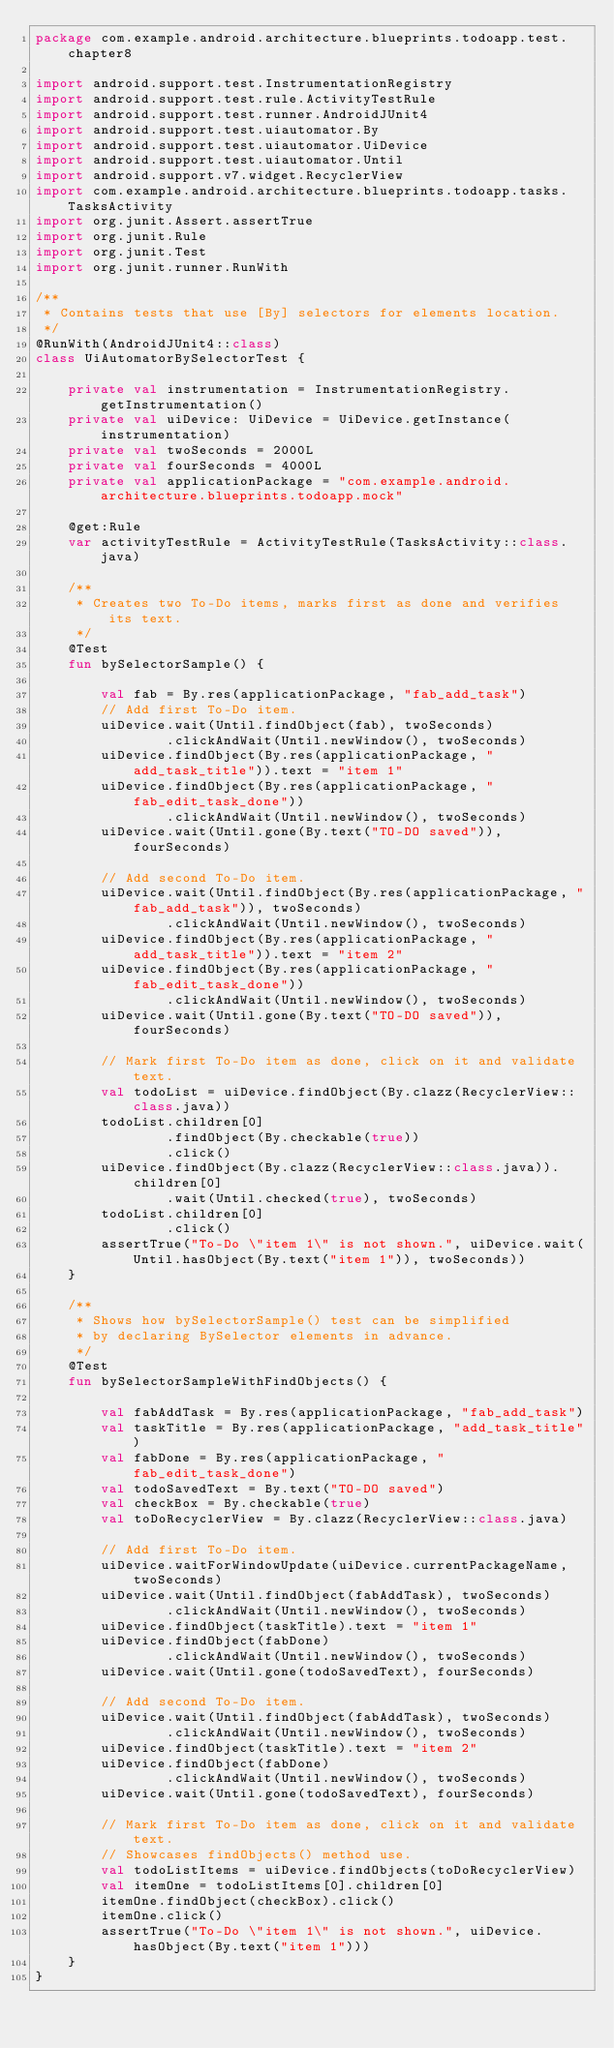Convert code to text. <code><loc_0><loc_0><loc_500><loc_500><_Kotlin_>package com.example.android.architecture.blueprints.todoapp.test.chapter8

import android.support.test.InstrumentationRegistry
import android.support.test.rule.ActivityTestRule
import android.support.test.runner.AndroidJUnit4
import android.support.test.uiautomator.By
import android.support.test.uiautomator.UiDevice
import android.support.test.uiautomator.Until
import android.support.v7.widget.RecyclerView
import com.example.android.architecture.blueprints.todoapp.tasks.TasksActivity
import org.junit.Assert.assertTrue
import org.junit.Rule
import org.junit.Test
import org.junit.runner.RunWith

/**
 * Contains tests that use [By] selectors for elements location.
 */
@RunWith(AndroidJUnit4::class)
class UiAutomatorBySelectorTest {

    private val instrumentation = InstrumentationRegistry.getInstrumentation()
    private val uiDevice: UiDevice = UiDevice.getInstance(instrumentation)
    private val twoSeconds = 2000L
    private val fourSeconds = 4000L
    private val applicationPackage = "com.example.android.architecture.blueprints.todoapp.mock"

    @get:Rule
    var activityTestRule = ActivityTestRule(TasksActivity::class.java)

    /**
     * Creates two To-Do items, marks first as done and verifies its text.
     */
    @Test
    fun bySelectorSample() {

        val fab = By.res(applicationPackage, "fab_add_task")
        // Add first To-Do item.
        uiDevice.wait(Until.findObject(fab), twoSeconds)
                .clickAndWait(Until.newWindow(), twoSeconds)
        uiDevice.findObject(By.res(applicationPackage, "add_task_title")).text = "item 1"
        uiDevice.findObject(By.res(applicationPackage, "fab_edit_task_done"))
                .clickAndWait(Until.newWindow(), twoSeconds)
        uiDevice.wait(Until.gone(By.text("TO-DO saved")), fourSeconds)

        // Add second To-Do item.
        uiDevice.wait(Until.findObject(By.res(applicationPackage, "fab_add_task")), twoSeconds)
                .clickAndWait(Until.newWindow(), twoSeconds)
        uiDevice.findObject(By.res(applicationPackage, "add_task_title")).text = "item 2"
        uiDevice.findObject(By.res(applicationPackage, "fab_edit_task_done"))
                .clickAndWait(Until.newWindow(), twoSeconds)
        uiDevice.wait(Until.gone(By.text("TO-DO saved")), fourSeconds)

        // Mark first To-Do item as done, click on it and validate text.
        val todoList = uiDevice.findObject(By.clazz(RecyclerView::class.java))
        todoList.children[0]
                .findObject(By.checkable(true))
                .click()
        uiDevice.findObject(By.clazz(RecyclerView::class.java)).children[0]
                .wait(Until.checked(true), twoSeconds)
        todoList.children[0]
                .click()
        assertTrue("To-Do \"item 1\" is not shown.", uiDevice.wait(Until.hasObject(By.text("item 1")), twoSeconds))
    }

    /**
     * Shows how bySelectorSample() test can be simplified
     * by declaring BySelector elements in advance.
     */
    @Test
    fun bySelectorSampleWithFindObjects() {

        val fabAddTask = By.res(applicationPackage, "fab_add_task")
        val taskTitle = By.res(applicationPackage, "add_task_title")
        val fabDone = By.res(applicationPackage, "fab_edit_task_done")
        val todoSavedText = By.text("TO-DO saved")
        val checkBox = By.checkable(true)
        val toDoRecyclerView = By.clazz(RecyclerView::class.java)

        // Add first To-Do item.
        uiDevice.waitForWindowUpdate(uiDevice.currentPackageName, twoSeconds)
        uiDevice.wait(Until.findObject(fabAddTask), twoSeconds)
                .clickAndWait(Until.newWindow(), twoSeconds)
        uiDevice.findObject(taskTitle).text = "item 1"
        uiDevice.findObject(fabDone)
                .clickAndWait(Until.newWindow(), twoSeconds)
        uiDevice.wait(Until.gone(todoSavedText), fourSeconds)

        // Add second To-Do item.
        uiDevice.wait(Until.findObject(fabAddTask), twoSeconds)
                .clickAndWait(Until.newWindow(), twoSeconds)
        uiDevice.findObject(taskTitle).text = "item 2"
        uiDevice.findObject(fabDone)
                .clickAndWait(Until.newWindow(), twoSeconds)
        uiDevice.wait(Until.gone(todoSavedText), fourSeconds)

        // Mark first To-Do item as done, click on it and validate text.
        // Showcases findObjects() method use.
        val todoListItems = uiDevice.findObjects(toDoRecyclerView)
        val itemOne = todoListItems[0].children[0]
        itemOne.findObject(checkBox).click()
        itemOne.click()
        assertTrue("To-Do \"item 1\" is not shown.", uiDevice.hasObject(By.text("item 1")))
    }
}
</code> 